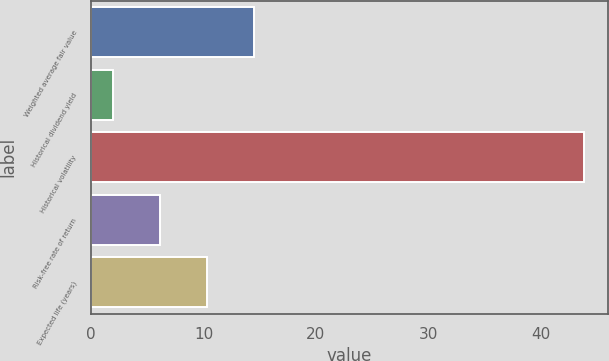<chart> <loc_0><loc_0><loc_500><loc_500><bar_chart><fcel>Weighted average fair value<fcel>Historical dividend yield<fcel>Historical volatility<fcel>Risk-free rate of return<fcel>Expected life (years)<nl><fcel>14.47<fcel>1.9<fcel>43.8<fcel>6.09<fcel>10.28<nl></chart> 